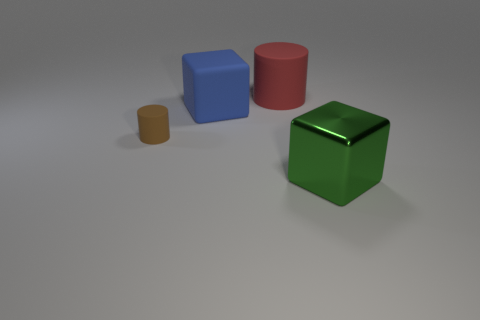Add 4 green metallic blocks. How many objects exist? 8 Subtract 1 cylinders. How many cylinders are left? 1 Subtract all red blocks. How many brown cylinders are left? 1 Subtract all blue matte cubes. Subtract all big green cubes. How many objects are left? 2 Add 1 brown cylinders. How many brown cylinders are left? 2 Add 1 matte cylinders. How many matte cylinders exist? 3 Subtract all brown cylinders. How many cylinders are left? 1 Subtract 0 cyan balls. How many objects are left? 4 Subtract all blue blocks. Subtract all green spheres. How many blocks are left? 1 